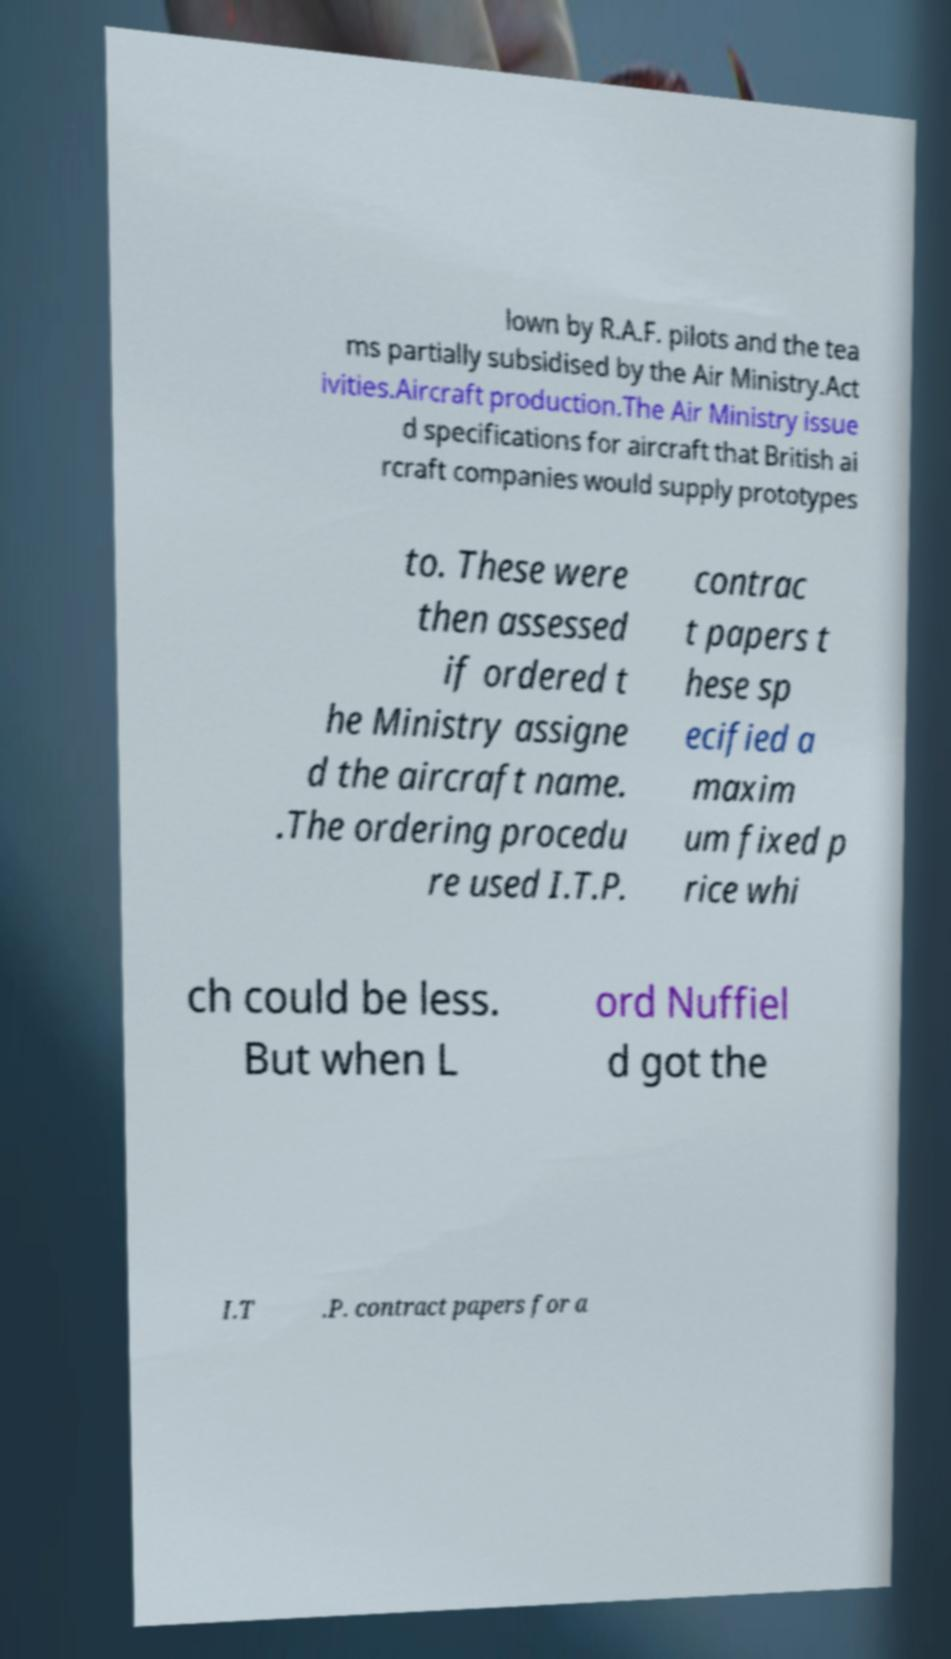Can you read and provide the text displayed in the image?This photo seems to have some interesting text. Can you extract and type it out for me? lown by R.A.F. pilots and the tea ms partially subsidised by the Air Ministry.Act ivities.Aircraft production.The Air Ministry issue d specifications for aircraft that British ai rcraft companies would supply prototypes to. These were then assessed if ordered t he Ministry assigne d the aircraft name. .The ordering procedu re used I.T.P. contrac t papers t hese sp ecified a maxim um fixed p rice whi ch could be less. But when L ord Nuffiel d got the I.T .P. contract papers for a 